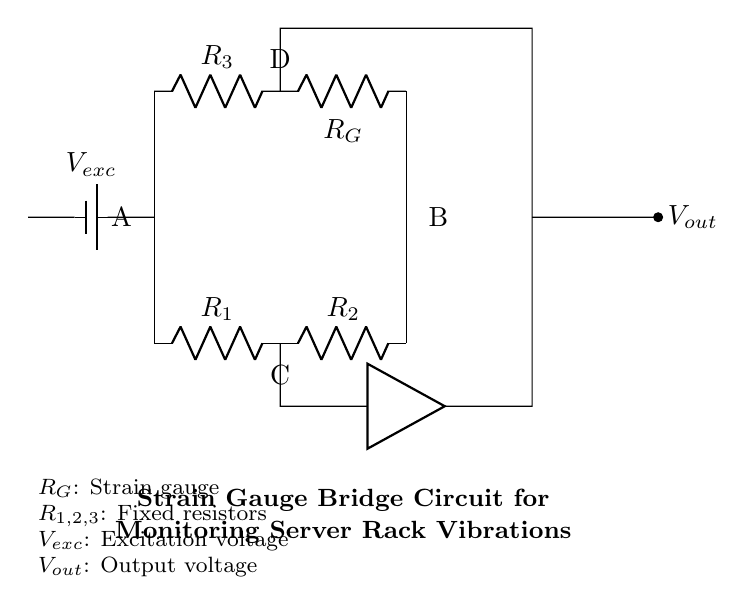What is the excitation voltage in the circuit? The excitation voltage is represented by the battery in the diagram, labeled as V_exc. Therefore, it is the voltage supplied to the bridge circuit for operation.
Answer: V_exc How many resistors are present in the circuit? The circuit contains three fixed resistors (R1, R2, R3) and one strain gauge (RG), making a total of four resistors.
Answer: Four What is the purpose of the strain gauge component? The strain gauge (RG) is used to measure the deformation or strain experienced due to vibrations in the server rack, thus providing feedback on the operational stability of the server.
Answer: Measure strain What do points A and B represent in the circuit? Points A and B are the connection terminals of the bridge circuit; A is connected to the voltage source and point B connects to the output voltage measuring point.
Answer: Connection terminals How does an imbalance in the bridge affect the output voltage? An imbalance in the bridge occurs when the resistance values are unequal, which produces a differential voltage at the output (V_out), indicating the level of strain. The output voltage changes in proportion to the amount of deformation detected by the strain gauge.
Answer: Affects output voltage What type of circuit is this? The circuit is a Wheatstone bridge configuration specifically designed for measuring resistance changes associated with strain gauges in order to monitor vibrations accurately.
Answer: Wheatstone bridge What is the relationship between the fixed resistors and the strain gauge in generating output? The fixed resistors (R1, R2, R3) form a balanced bridge circuit. When the strain gauge (RG) changes resistance due to vibration, it affects the overall balance, leading to an output voltage proportionate to that resistance variation, allowing for precise monitoring of server vibrations.
Answer: Generates output voltage 